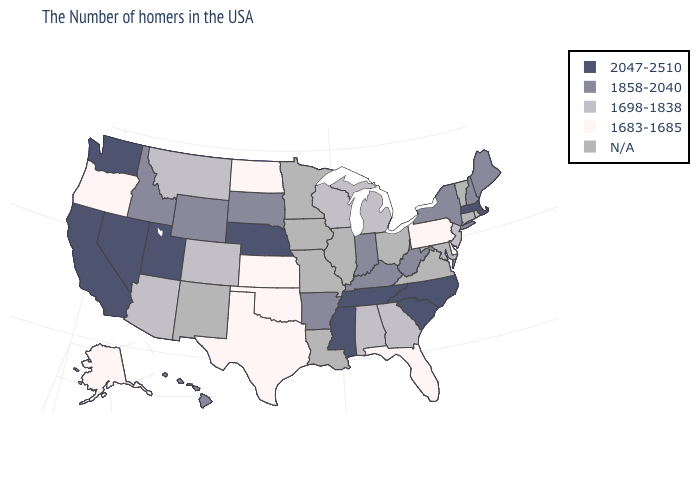What is the lowest value in the MidWest?
Keep it brief. 1683-1685. What is the value of Mississippi?
Give a very brief answer. 2047-2510. Name the states that have a value in the range 1698-1838?
Be succinct. Rhode Island, New Jersey, Georgia, Michigan, Alabama, Wisconsin, Colorado, Montana, Arizona. Does Pennsylvania have the lowest value in the Northeast?
Write a very short answer. Yes. Name the states that have a value in the range N/A?
Keep it brief. Vermont, Connecticut, Maryland, Virginia, Ohio, Illinois, Louisiana, Missouri, Minnesota, Iowa, New Mexico. Does Pennsylvania have the lowest value in the USA?
Short answer required. Yes. Which states have the lowest value in the USA?
Give a very brief answer. Delaware, Pennsylvania, Florida, Kansas, Oklahoma, Texas, North Dakota, Oregon, Alaska. What is the value of Oregon?
Be succinct. 1683-1685. Does Nevada have the highest value in the USA?
Give a very brief answer. Yes. What is the value of Montana?
Keep it brief. 1698-1838. Does Washington have the highest value in the USA?
Short answer required. Yes. Name the states that have a value in the range 2047-2510?
Quick response, please. Massachusetts, North Carolina, South Carolina, Tennessee, Mississippi, Nebraska, Utah, Nevada, California, Washington. What is the highest value in the West ?
Concise answer only. 2047-2510. 